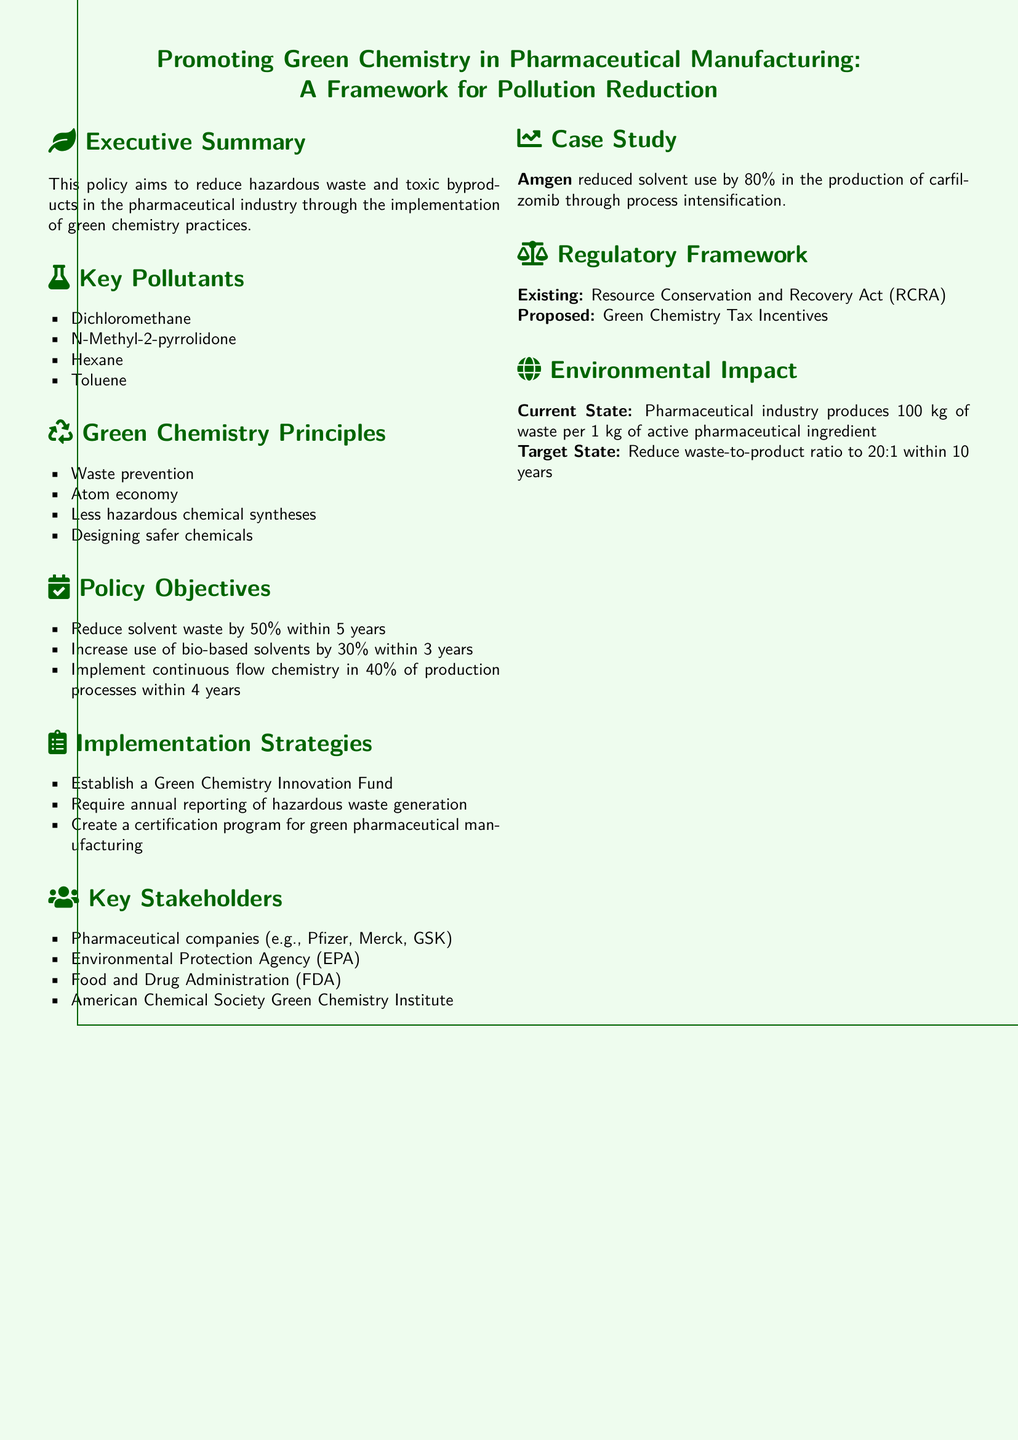What is the main goal of the policy? The policy aims to reduce hazardous waste and toxic byproducts in the pharmaceutical industry.
Answer: Reduce hazardous waste and toxic byproducts What pollutants are specifically mentioned? The document lists key pollutants which include dichloromethane, N-Methyl-2-pyrrolidone, hexane, and toluene.
Answer: Dichloromethane, N-Methyl-2-pyrrolidone, hexane, toluene What is the target reduction of solvent waste within five years? The policy objective specifies reducing solvent waste by 50% within a specified time frame.
Answer: 50% What percentage of production processes should implement continuous flow chemistry within four years? The implementation strategy outlines a target for 40% of production processes to adopt this practice.
Answer: 40% Which organizations are considered key stakeholders? The document lists pharmaceutical companies, EPA, FDA, and ACS Green Chemistry Institute as stakeholders.
Answer: Pharmaceutical companies, EPA, FDA, ACS Green Chemistry Institute What is the current waste-to-product ratio in the pharmaceutical industry? The document presents the current state metric indicating a waste-to-product ratio of 100 kg of waste per 1 kg of active pharmaceutical ingredient.
Answer: 100 kg waste per 1 kg active ingredient What is one strategy to promote green chemistry mentioned in the implementation section? The document lists the establishment of a Green Chemistry Innovation Fund as one of the strategies.
Answer: Establish a Green Chemistry Innovation Fund What incentive is proposed under the regulatory framework? The document suggests the introduction of Green Chemistry Tax Incentives as a proposed regulatory measure.
Answer: Green Chemistry Tax Incentives 